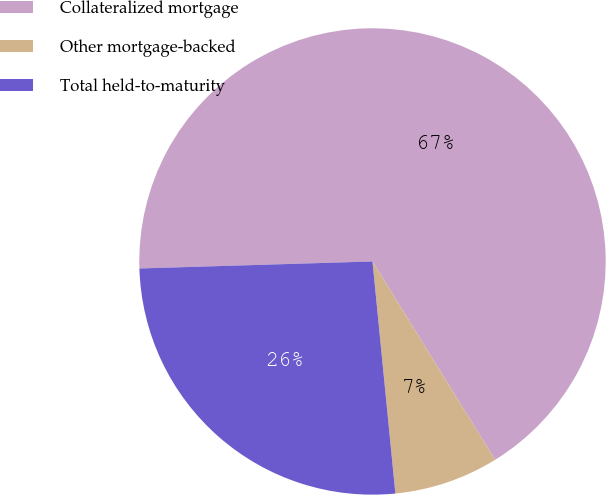Convert chart to OTSL. <chart><loc_0><loc_0><loc_500><loc_500><pie_chart><fcel>Collateralized mortgage<fcel>Other mortgage-backed<fcel>Total held-to-maturity<nl><fcel>66.67%<fcel>7.25%<fcel>26.09%<nl></chart> 